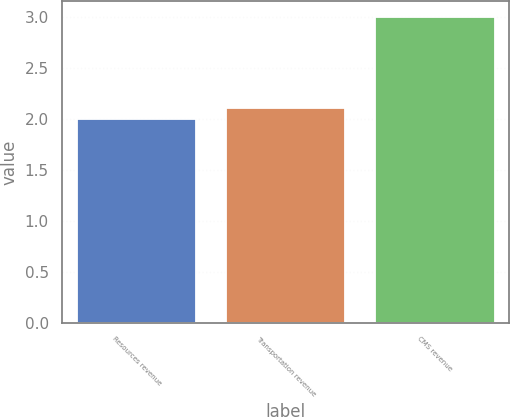<chart> <loc_0><loc_0><loc_500><loc_500><bar_chart><fcel>Resources revenue<fcel>Transportation revenue<fcel>CMS revenue<nl><fcel>2<fcel>2.1<fcel>3<nl></chart> 